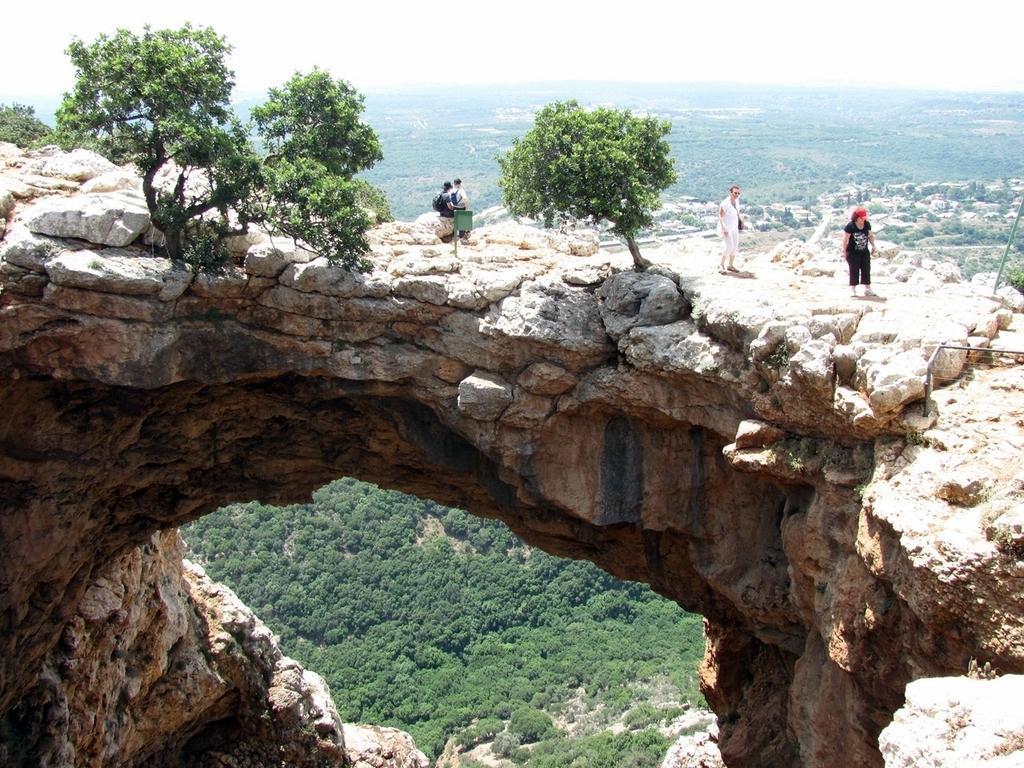Describe this image in one or two sentences. In this image I can see few people and few trees in the centre. I can also see green colour things in the front and in the background of this image. 